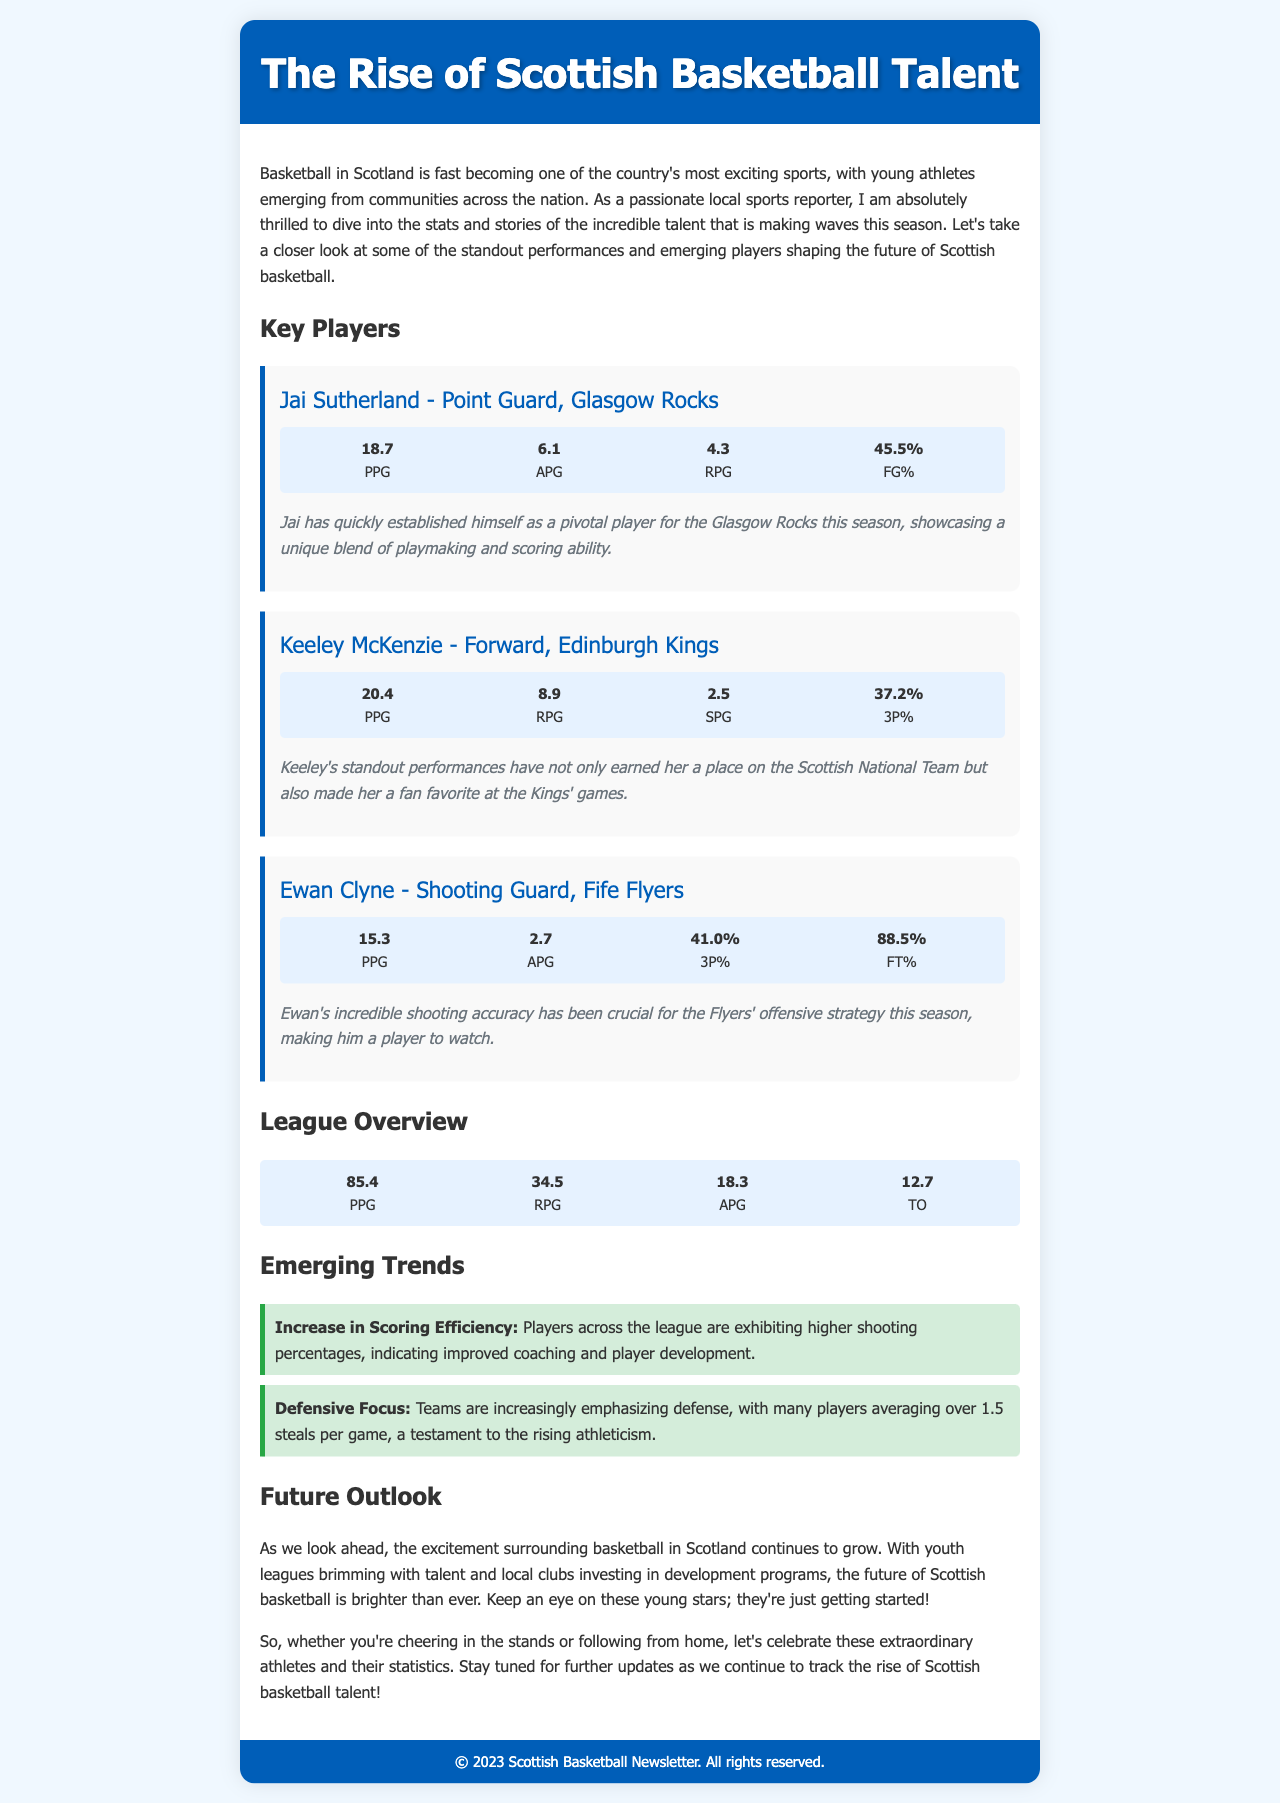What is Jai Sutherland's PPG? Jai Sutherland has a points per game (PPG) statistic of 18.7 in the document.
Answer: 18.7 How many rebounds per game does Keeley McKenzie average? Keeley McKenzie averages 8.9 rebounds per game (RPG) as stated in the document.
Answer: 8.9 What is Ewan Clyne's free throw percentage? Ewan Clyne's free throw percentage (FT%) is 88.5% as per the information given.
Answer: 88.5% What is the average points per game for the league? The document indicates the average points per game (PPG) for the league is 85.4.
Answer: 85.4 Which team is Jai Sutherland associated with? Jai Sutherland is associated with the Glasgow Rocks as mentioned in the document.
Answer: Glasgow Rocks What trend is observed regarding scoring efficiency in the league? There is an increase in scoring efficiency noted in the document, reflecting improved coaching and player development.
Answer: Increase in Scoring Efficiency Who has made it to the Scottish National Team according to the newsletter? Keeley McKenzie has earned her place on the Scottish National Team as stated in the document.
Answer: Keeley McKenzie What is the primary focus of teams in the current season? The primary focus of teams is defense, as highlighted in the trends section of the document.
Answer: Defensive Focus 